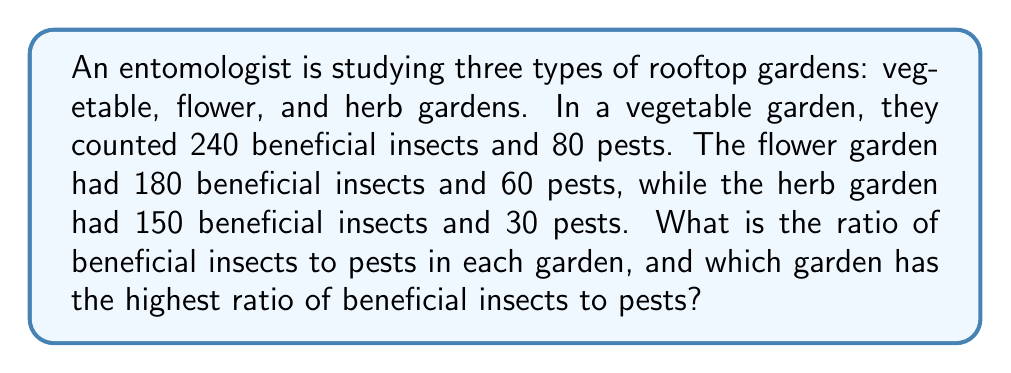Can you solve this math problem? To solve this problem, we need to calculate the ratio of beneficial insects to pests for each garden type and then compare them.

1. Vegetable garden:
   Beneficial insects: 240
   Pests: 80
   Ratio = $\frac{240}{80} = \frac{3}{1} = 3:1$

2. Flower garden:
   Beneficial insects: 180
   Pests: 60
   Ratio = $\frac{180}{60} = \frac{3}{1} = 3:1$

3. Herb garden:
   Beneficial insects: 150
   Pests: 30
   Ratio = $\frac{150}{30} = \frac{5}{1} = 5:1$

To compare the ratios, we can express them as decimals:
Vegetable garden: $3:1 = 3$
Flower garden: $3:1 = 3$
Herb garden: $5:1 = 5$

The herb garden has the highest ratio of beneficial insects to pests.
Answer: The ratios of beneficial insects to pests are:
Vegetable garden: 3:1
Flower garden: 3:1
Herb garden: 5:1

The herb garden has the highest ratio of beneficial insects to pests. 